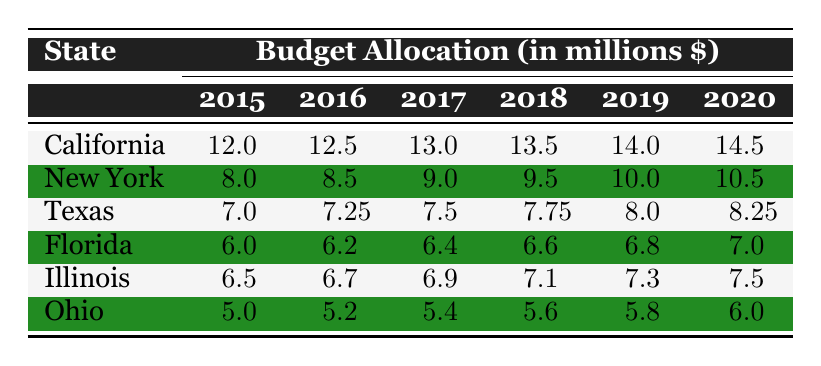What was the budget allocation for California in 2018? The table shows that California had a budget allocation of 13.5 million dollars in 2018.
Answer: 13.5 million dollars Which state had the highest budget allocation in 2020? In 2020, California had a budget allocation of 14.5 million dollars, which is higher than New York (10.5 million), Texas (8.25 million), Florida (7 million), Illinois (7.5 million), and Ohio (6 million).
Answer: California What was the total budget allocation for Ohio from 2015 to 2020? Adding Ohio's budget allocations: 5.0 + 5.2 + 5.4 + 5.6 + 5.8 + 6.0 = 33.0 million dollars.
Answer: 33.0 million dollars Did Florida's budget allocation increase every year from 2015 to 2020? Observing the data for Florida: 6.0 million in 2015, 6.2 million in 2016, 6.4 million in 2017, 6.6 million in 2018, 6.8 million in 2019, and 7.0 million in 2020 shows a consistent increase each year.
Answer: Yes What was the average budget allocation for Illinois over the years listed? Calculating the average for Illinois: (6.5 + 6.7 + 6.9 + 7.1 + 7.3 + 7.5) = 42.0 million dollars. There are 6 entries, so the average is 42.0 / 6 = 7.0 million dollars.
Answer: 7.0 million dollars Which state had the smallest budget allocation in 2015, and what was that amount? By examining the table, we see that Ohio had the smallest allocation in 2015 at 5.0 million dollars compared to other states.
Answer: Ohio, 5.0 million dollars What was the increase in budget allocation for Texas from 2015 to 2020? Texas had a budget of 7.0 million dollars in 2015 and 8.25 million dollars in 2020. The increase is calculated as 8.25 - 7.0 = 1.25 million dollars.
Answer: 1.25 million dollars Which year saw the largest increase in budget allocation for New York? The allocations for New York are: 8.0, 8.5, 9.0, 9.5, 10.0, and 10.5 million dollars. The largest increase was from 2015 to 2016, from 8.0 to 8.5 million dollars, which is 0.5 million dollars.
Answer: 2015 to 2016 Was the budget for California higher than that of Texas for all years listed? Analyzing the data, California's allocations (12.0 to 14.5 million) exceed Texas's allocations (7.0 to 8.25 million) consistently across all years from 2015 to 2020.
Answer: Yes 